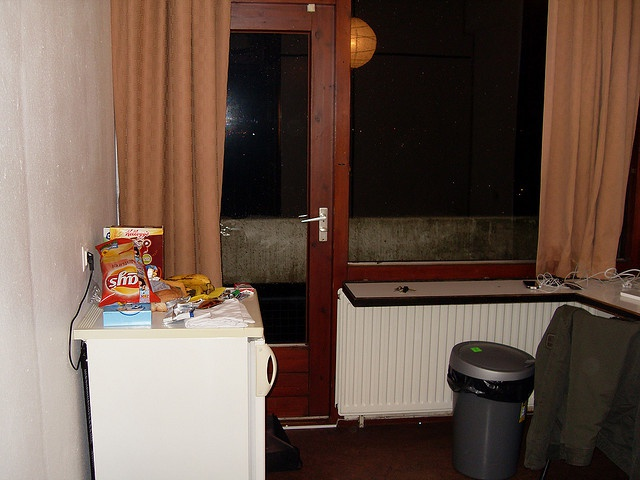Describe the objects in this image and their specific colors. I can see refrigerator in darkgray, lightgray, black, and tan tones, chair in darkgray, black, and gray tones, banana in darkgray, olive, maroon, and orange tones, cell phone in darkgray, black, maroon, and gray tones, and cell phone in darkgray, black, maroon, and brown tones in this image. 